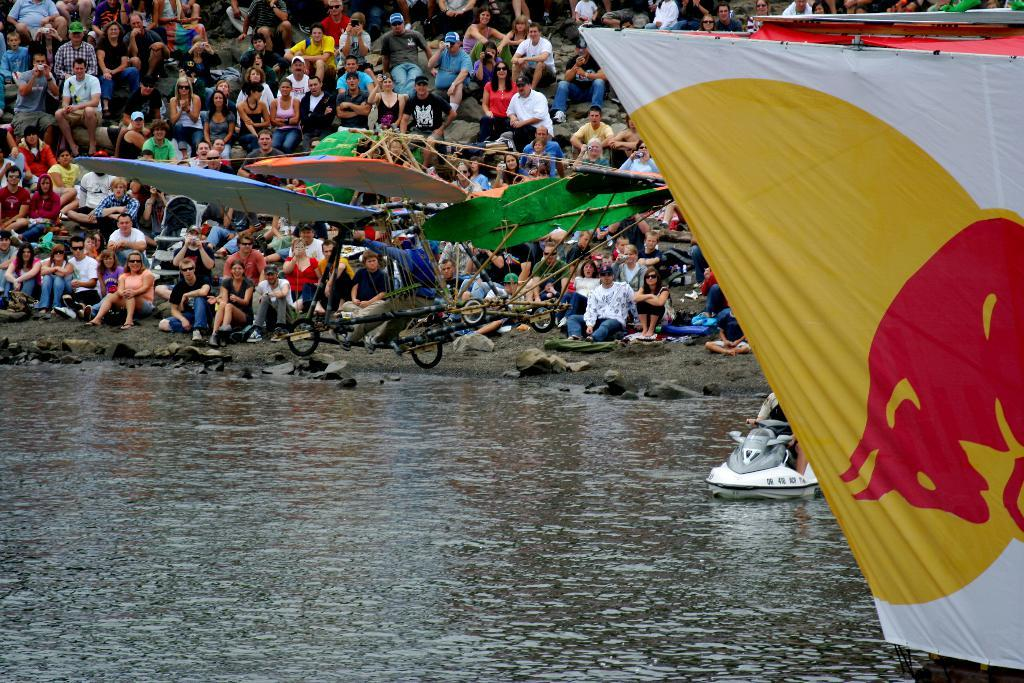What are the people in the image doing? There is a group of people sitting on the ground in the image. What can be seen in the background of the image? Boats are visible on the water in the image. Can you describe any other objects present in the image? There are other objects present in the image, but their specific details are not mentioned in the provided facts. What type of company is represented by the logo on the ground in the image? There is no logo or company mentioned in the image, as the provided facts only mention a group of people sitting on the ground and boats visible on the water. 